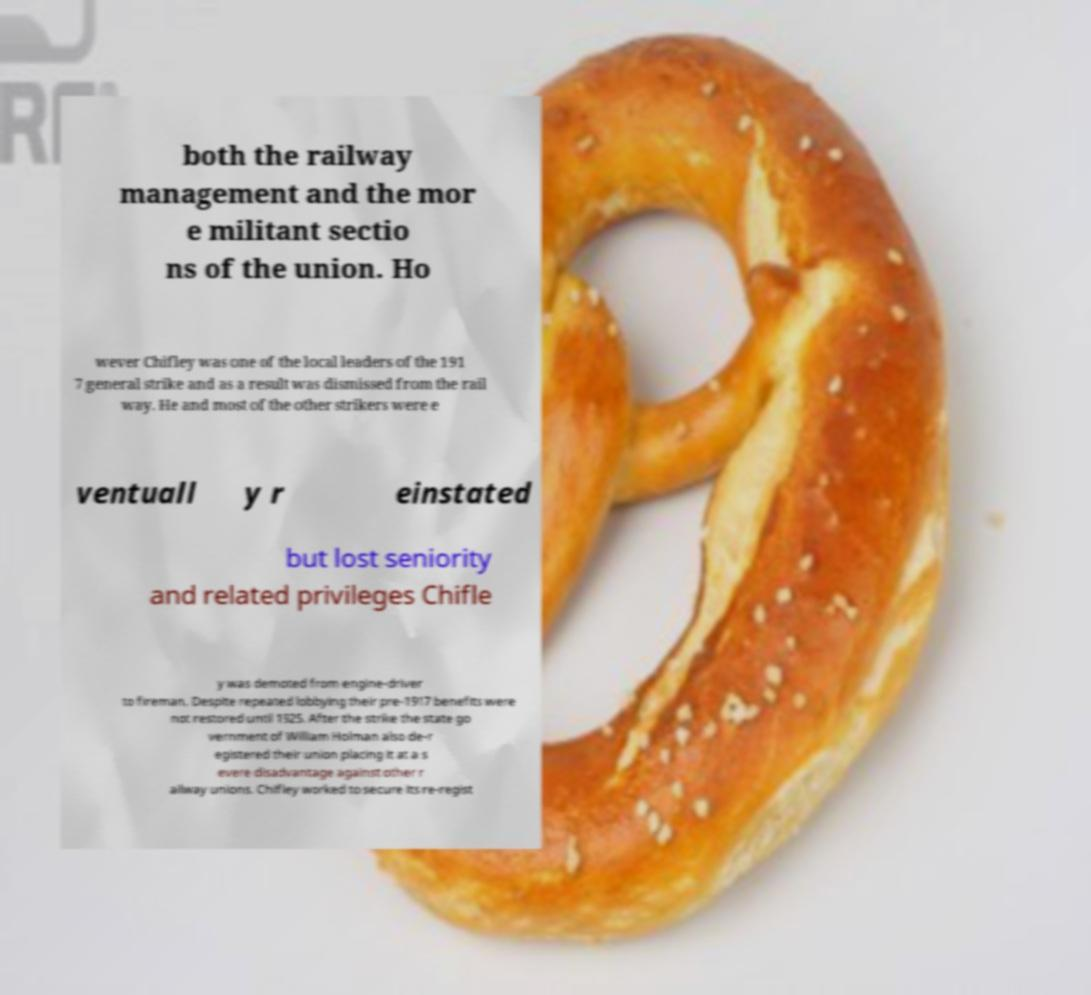Please identify and transcribe the text found in this image. both the railway management and the mor e militant sectio ns of the union. Ho wever Chifley was one of the local leaders of the 191 7 general strike and as a result was dismissed from the rail way. He and most of the other strikers were e ventuall y r einstated but lost seniority and related privileges Chifle y was demoted from engine-driver to fireman. Despite repeated lobbying their pre-1917 benefits were not restored until 1925. After the strike the state go vernment of William Holman also de-r egistered their union placing it at a s evere disadvantage against other r ailway unions. Chifley worked to secure its re-regist 